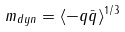<formula> <loc_0><loc_0><loc_500><loc_500>m _ { d y n } = \langle - q \bar { q } \rangle ^ { 1 / 3 }</formula> 